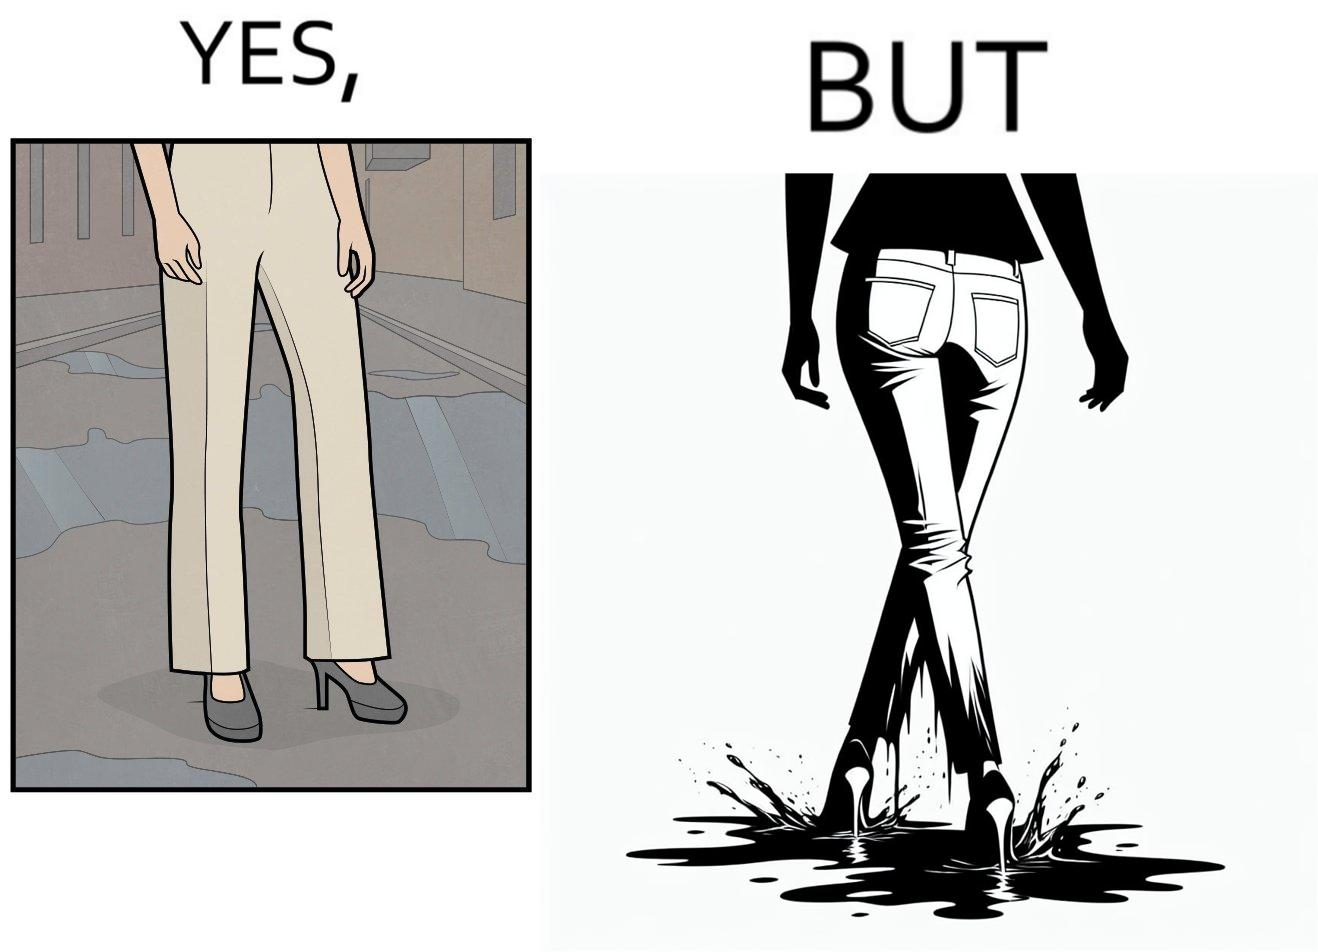Why is this image considered satirical? The image is funny, as when looking from the front, girl's pants are spick and span, while looking from the back, her pants are soaked in water, probably due to walking on a road filled with water in high heels. This is ironical, as the very reason for wearing heels (i.e. looking beautiful) is defeated, due to the heels themselves. 